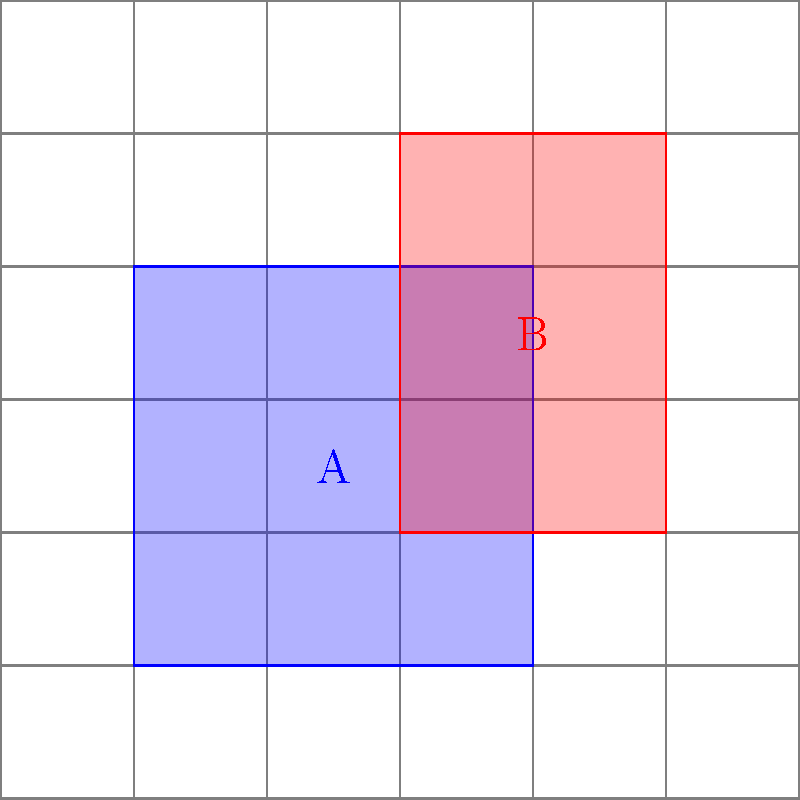In a grid-based system where each square has a side length of 1 unit, two rectangles A and B are positioned as shown in the diagram. Rectangle A (blue) has its bottom-left corner at (1,1) and top-right corner at (4,4). Rectangle B (red) has its bottom-left corner at (3,2) and top-right corner at (5,5). Calculate the total area covered by both rectangles, considering their overlap. To solve this problem, we'll follow these steps:

1. Calculate the area of Rectangle A:
   Width = 4 - 1 = 3 units
   Height = 4 - 1 = 3 units
   Area of A = $3 \times 3 = 9$ square units

2. Calculate the area of Rectangle B:
   Width = 5 - 3 = 2 units
   Height = 5 - 2 = 3 units
   Area of B = $2 \times 3 = 6$ square units

3. Calculate the area of overlap:
   The overlapping region has:
   Width = 4 - 3 = 1 unit
   Height = 4 - 2 = 2 units
   Area of overlap = $1 \times 2 = 2$ square units

4. Calculate the total area:
   Total Area = Area of A + Area of B - Area of overlap
   $\text{Total Area} = 9 + 6 - 2 = 13$ square units

The total area covered by both rectangles, accounting for the overlap, is 13 square units.
Answer: 13 square units 